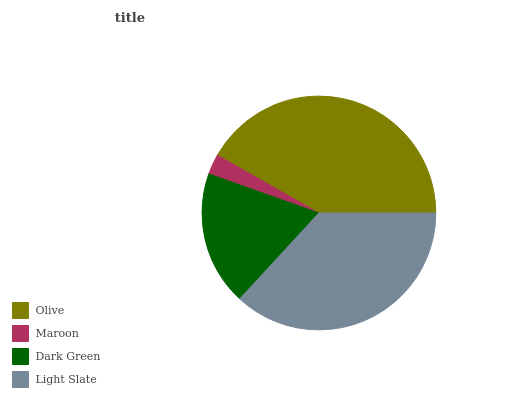Is Maroon the minimum?
Answer yes or no. Yes. Is Olive the maximum?
Answer yes or no. Yes. Is Dark Green the minimum?
Answer yes or no. No. Is Dark Green the maximum?
Answer yes or no. No. Is Dark Green greater than Maroon?
Answer yes or no. Yes. Is Maroon less than Dark Green?
Answer yes or no. Yes. Is Maroon greater than Dark Green?
Answer yes or no. No. Is Dark Green less than Maroon?
Answer yes or no. No. Is Light Slate the high median?
Answer yes or no. Yes. Is Dark Green the low median?
Answer yes or no. Yes. Is Dark Green the high median?
Answer yes or no. No. Is Light Slate the low median?
Answer yes or no. No. 